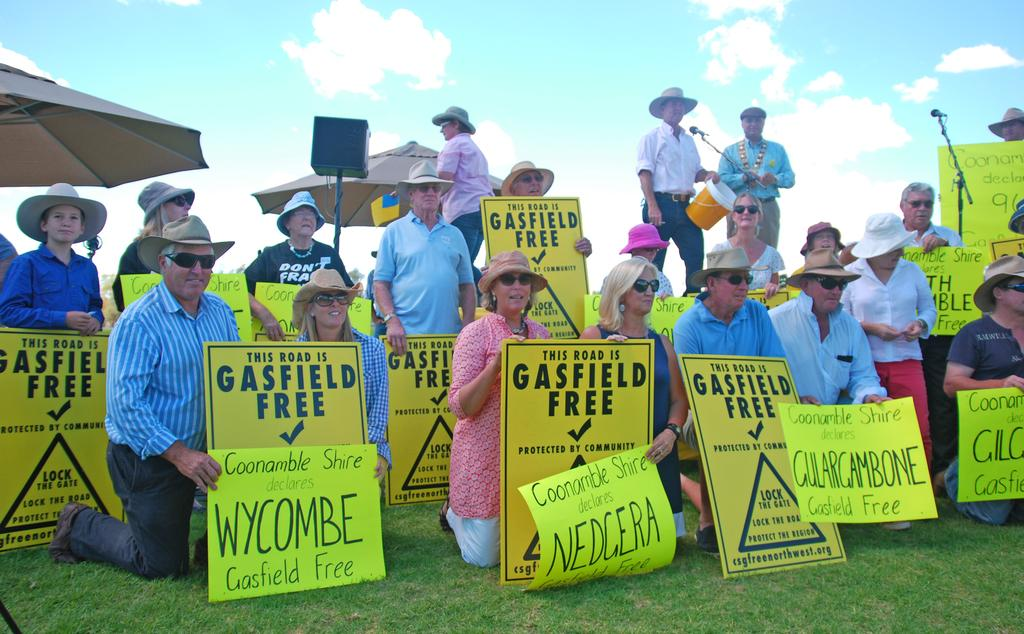What is happening in the center of the image? There are many persons in the center of the image. Where are the persons located? The persons are on the grass. What are the persons holding? The persons are holding boards. What can be seen in the background of the image? There are mics, persons, a speaker, umbrellas, the sky, and clouds in the background of the image. What type of hospital can be seen in the image? There is no hospital present in the image. Are there any spies visible in the image? There is no indication of spies in the image. 